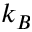<formula> <loc_0><loc_0><loc_500><loc_500>k _ { B }</formula> 